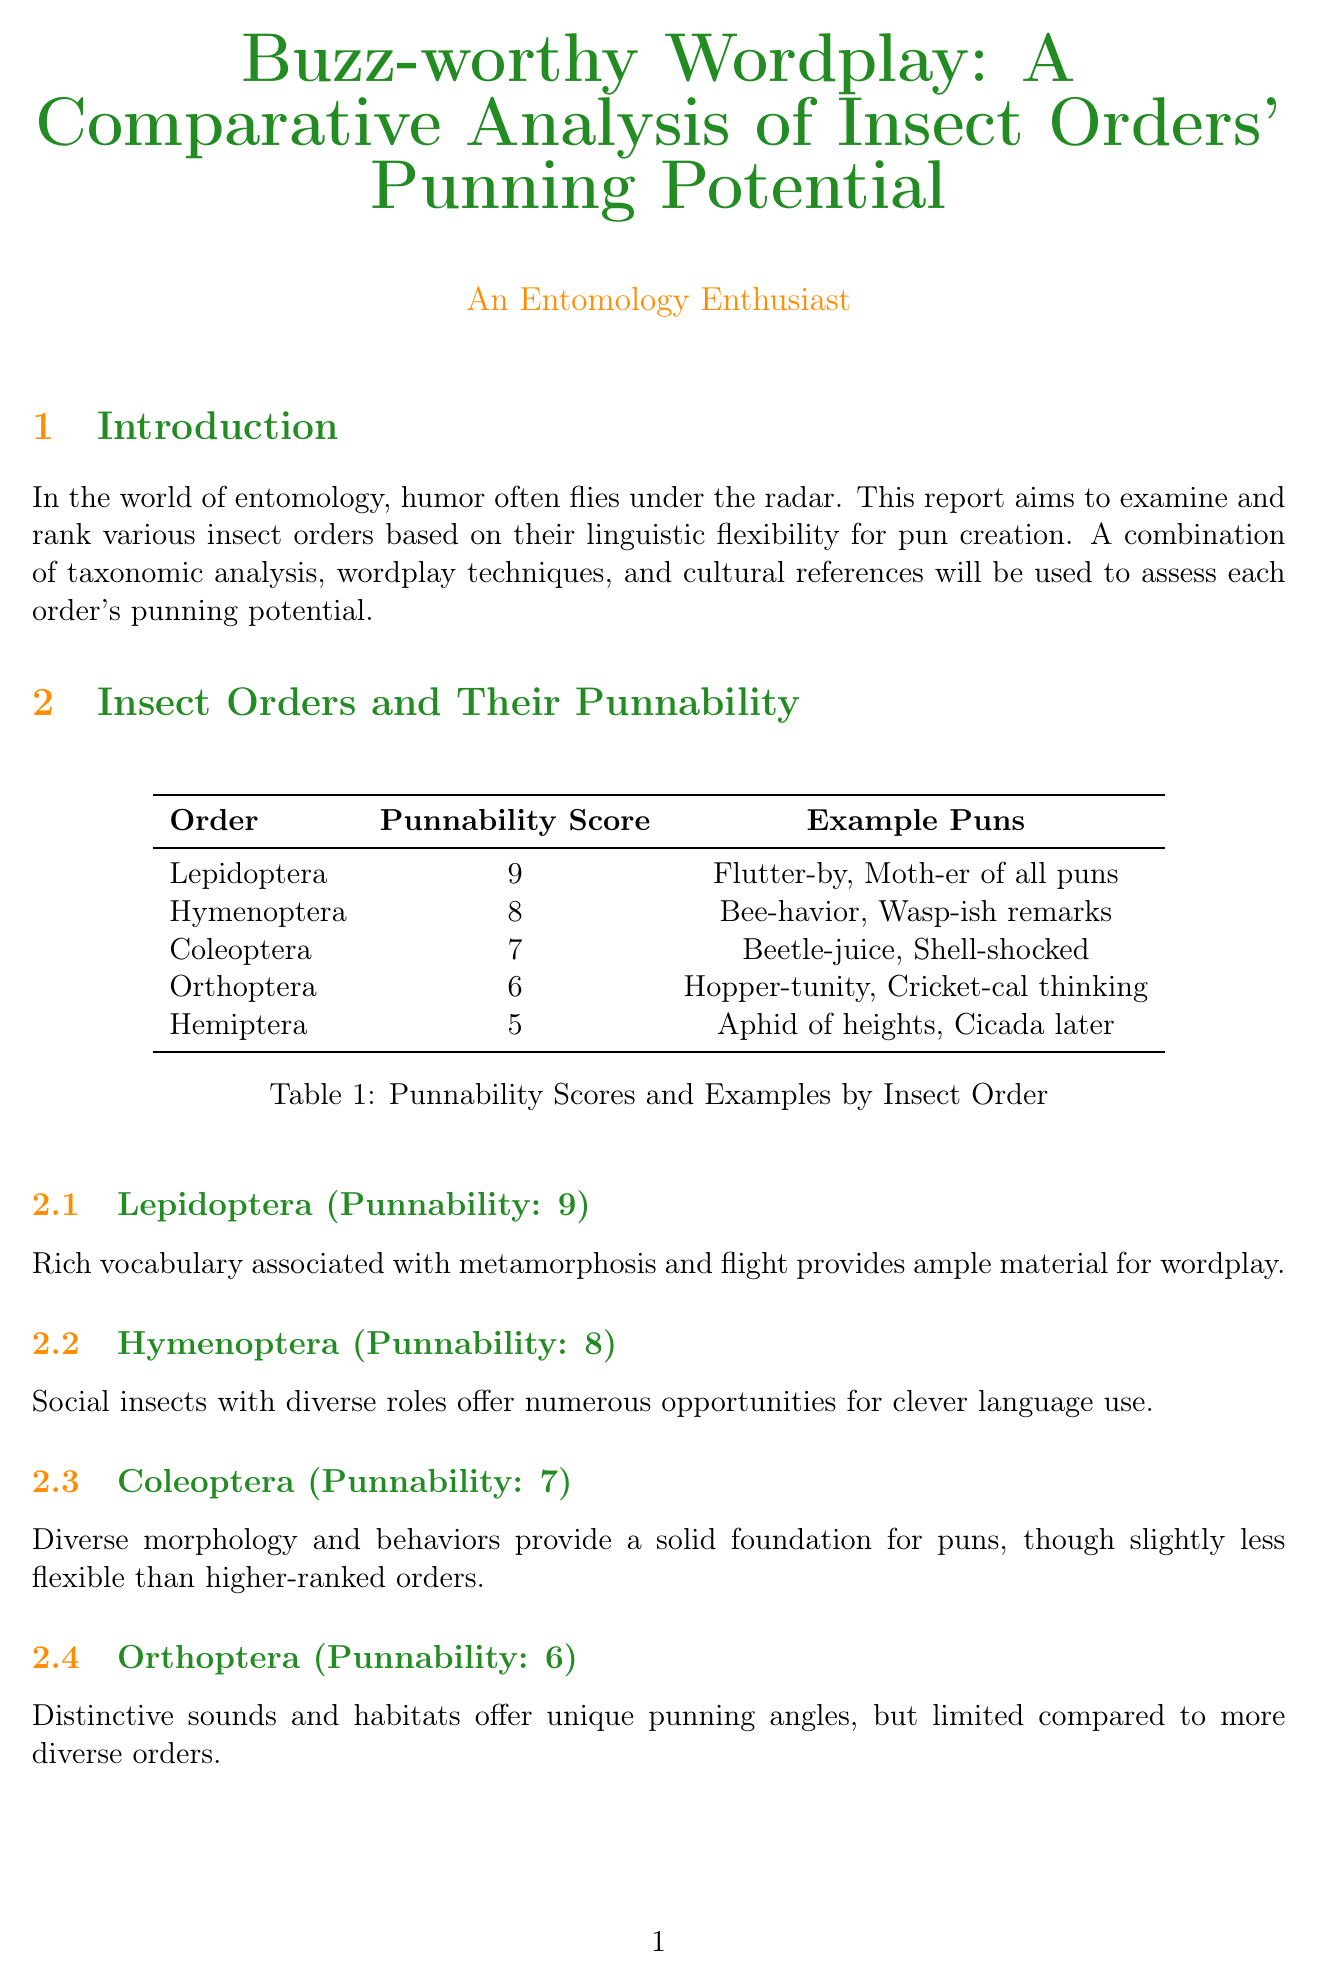What is the title of the report? The title of the report is stated at the beginning of the document as "Buzz-worthy Wordplay: A Comparative Analysis of Insect Orders' Punning Potential."
Answer: Buzz-worthy Wordplay: A Comparative Analysis of Insect Orders' Punning Potential Which insect order has the highest punnability score? The order with the highest punnability score is listed in the table with the score of 9.
Answer: Lepidoptera How many criteria are used in the ranking system? The number of criteria is outlined in the ranking system section as five distinct points.
Answer: 5 What is an example pun from the Hymenoptera order? The document provides examples of puns from the Hymenoptera order, one of which is highlighted.
Answer: Bee-havior Which insect order is considered the least pun-friendly according to the report? The report ranks the insect orders based on their punnability scores and identifies the lowest.
Answer: Hemiptera What is the average punnability score for Coleoptera? The document explicitly states the punnability score assigned to the Coleoptera order.
Answer: 7 Who is the author of the report? The author is introduced at the end of the document in the section labeled "About the Author."
Answer: An Entomology Enthusiast What song is mentioned in the cultural impact section? The cultural impact section references various songs, including one specific title.
Answer: Flight of the Bumblebee by Rimsky-Korsakov 